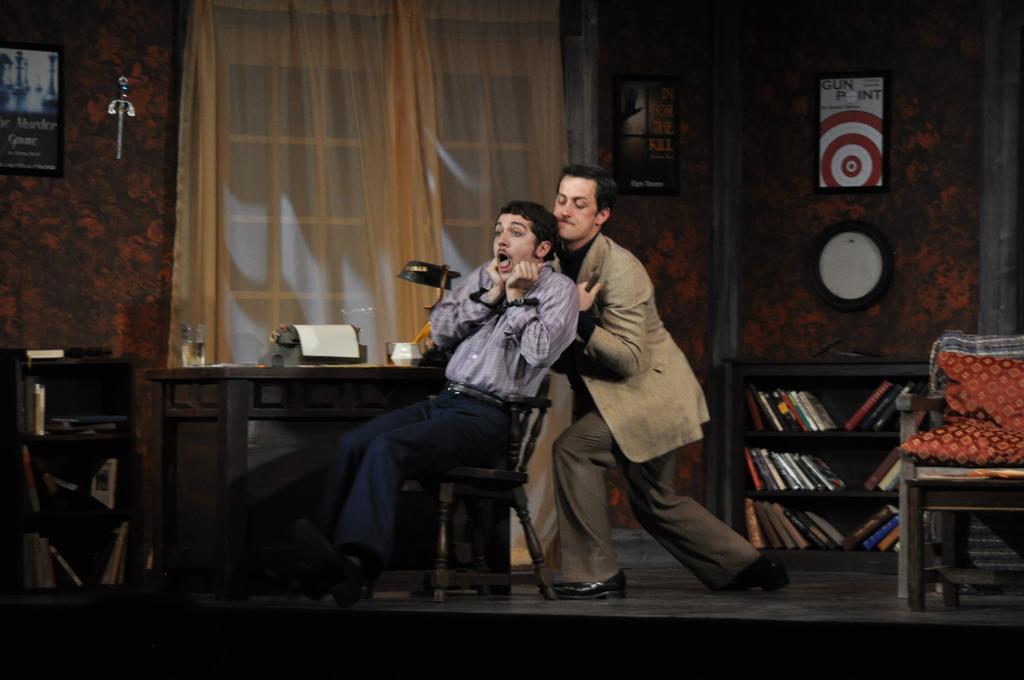Describe this image in one or two sentences. there are 2 people. the person at the front is sitting on the chair. the person at the back is pulling him down. behind them there is a book shelf and at the left there is a window curtain. 